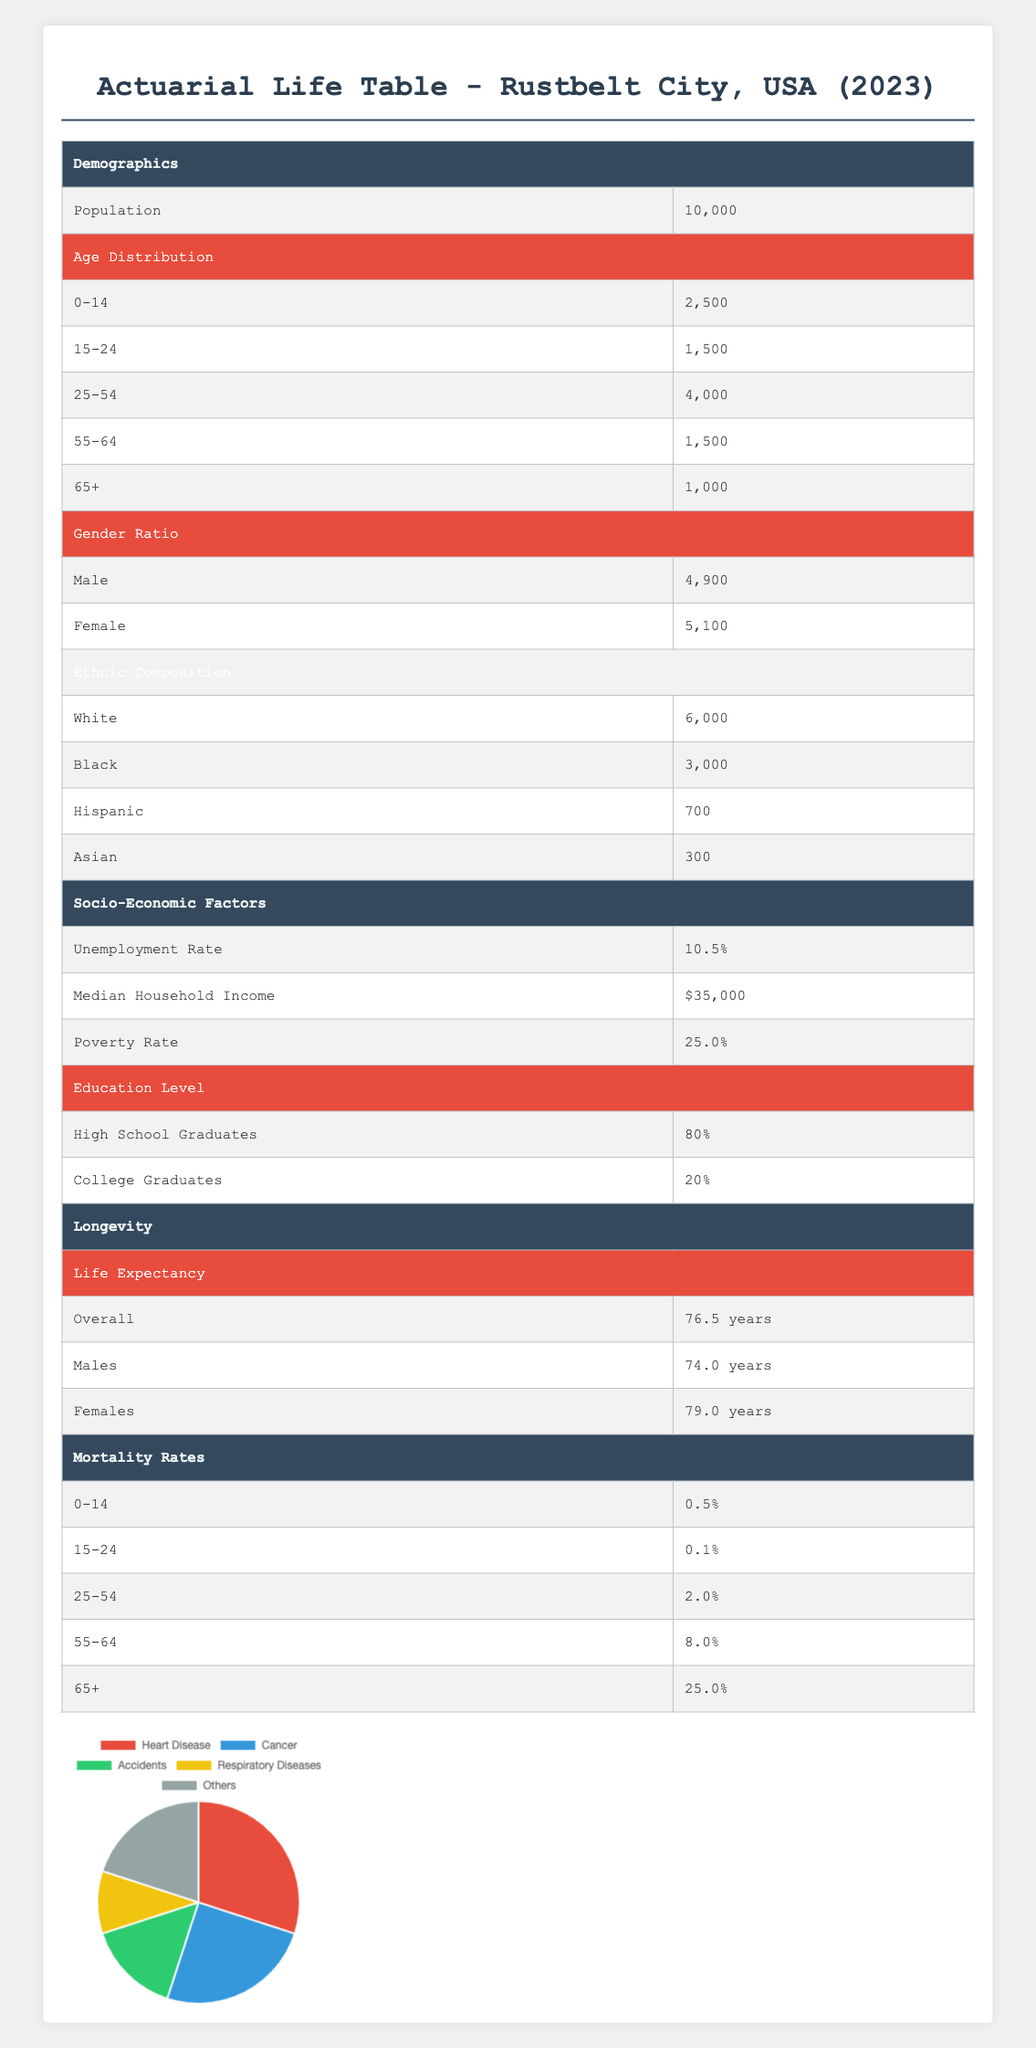What is the total population of Rustbelt City? The total population is listed in the Demographics section of the table under “Population,” which shows 10,000.
Answer: 10,000 What is the poverty rate in this community? The poverty rate is found in the Socio-Economic Factors section under "Poverty Rate," which indicates 25.0%.
Answer: 25.0% How many people are aged 25-54 in Rustbelt City? In the Age Distribution section, the number of people aged 25-54 is provided as 4,000.
Answer: 4,000 What is the average life expectancy for males and females combined? The overall life expectancy is given as 76.5 years, which combines the life expectancy of both males and females.
Answer: 76.5 years Is the median household income in Rustbelt City above or below $40,000? The median household income is listed as $35,000, which is below $40,000. Thus, the statement is false.
Answer: No What percentage of the population is female? The female population is 5,100 out of a total of 10,000. To find the percentage, divide 5,100 by 10,000 and multiply by 100, resulting in 51%.
Answer: 51% What is the mortality rate for individuals aged 55-64? The mortality rate for the age group 55-64 is clearly noted in the Mortality Rates section, showing 8.0%.
Answer: 8.0% How many individuals live in the 15-24 age group compared to those in the 25-54 age group? The table indicates that there are 1,500 individuals in the 15-24 age group and 4,000 in the 25-54 age group, showing that the latter has 2,500 more individuals (4,000 - 1,500).
Answer: 2,500 more What percentage of the population are college graduates in Rustbelt City? The table shows that 20% of the population are college graduates. This is a straightforward retrieval from the Education Level section.
Answer: 20% 